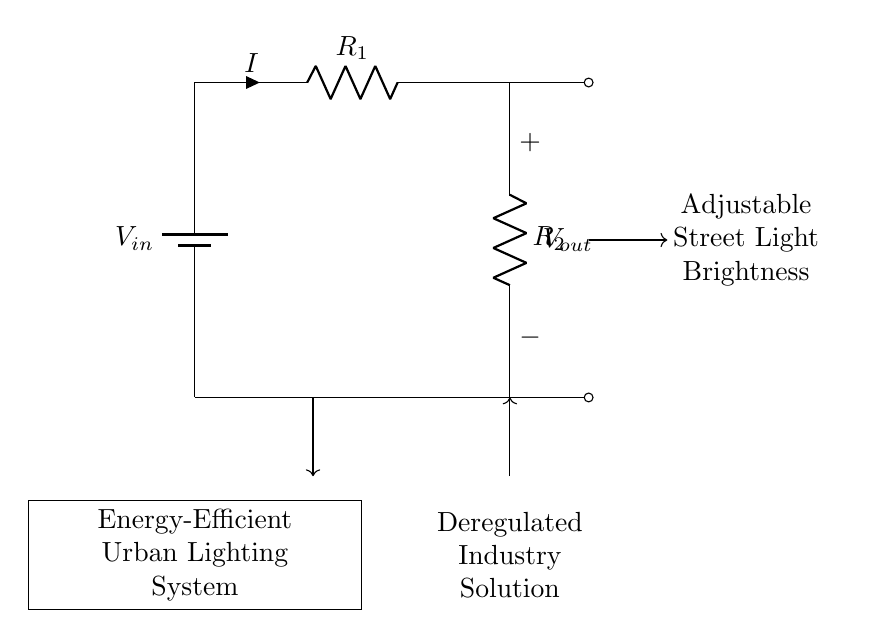What is the input voltage in this circuit? The input voltage, denoted as V_in, is the voltage source connected at the top of the circuit and typically represents the total voltage supplied to the voltage divider.
Answer: V_in What components are used in this voltage divider? The circuit contains two resistors, labeled R_1 and R_2, which together form the voltage divider. Additionally, there is a battery representing V_in.
Answer: R_1 and R_2 What does V_out represent in this circuit? V_out is the voltage across the second resistor, R_2. It's the output voltage that can be adjusted to control the brightness of the street light in the lighting system.
Answer: The voltage across R_2 What happens to V_out if R_1 increases while R_2 remains constant? If R_1 increases while R_2 stays the same, the output voltage V_out decreases due to the increased resistance in the voltage divider formula; this results in less voltage across R_2.
Answer: V_out decreases How does the voltage divider adjust street light brightness? The voltage divider allows for varying the output voltage V_out by changing the resistances R_1 and R_2, thereby controlling the power supplied to the street light, leading to adjustments in brightness.
Answer: By changing R_1 and R_2 What is the role of the wiring connections in this circuit? The connections guide the flow of current from the input voltage through R_1 and then R_2, ultimately leading to the output voltage V_out. They are crucial for the proper operation of the voltage divider.
Answer: Direct current flow What is the purpose of this energy-efficient urban lighting system? The system aims to efficiently manage street lighting by adjusting brightness levels as needed, contributing to energy savings within the urban environment.
Answer: Energy efficiency 